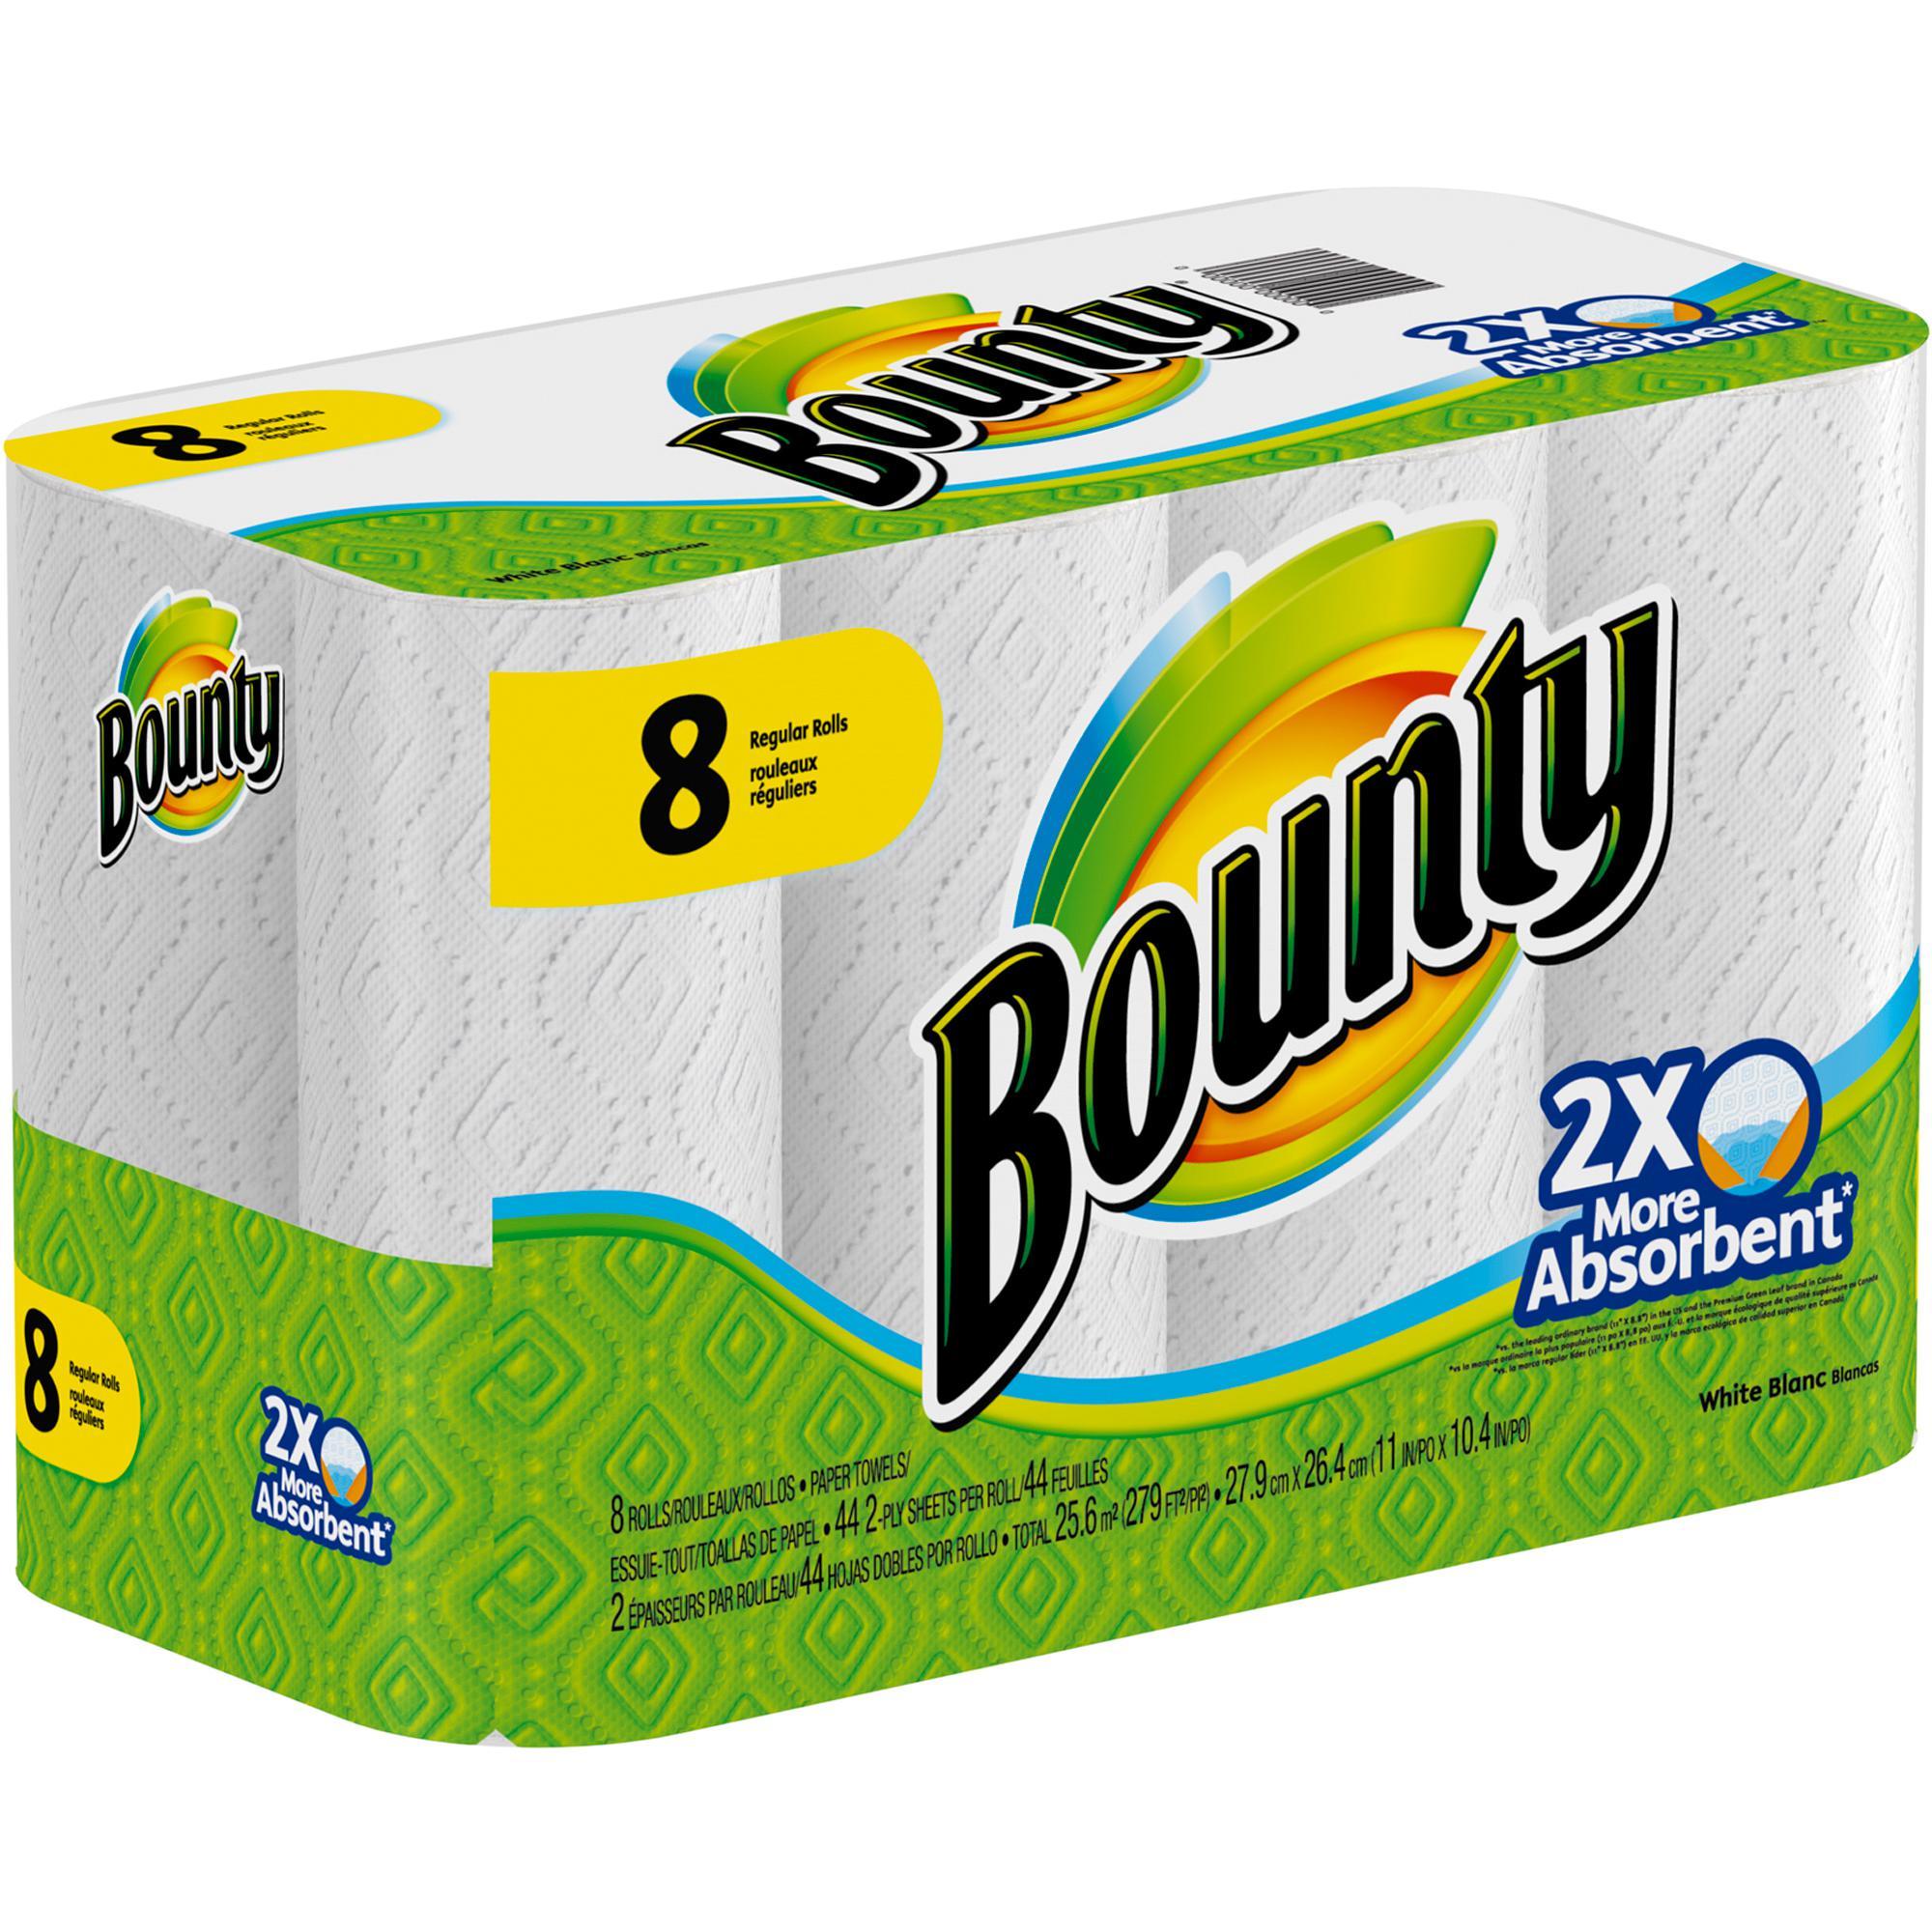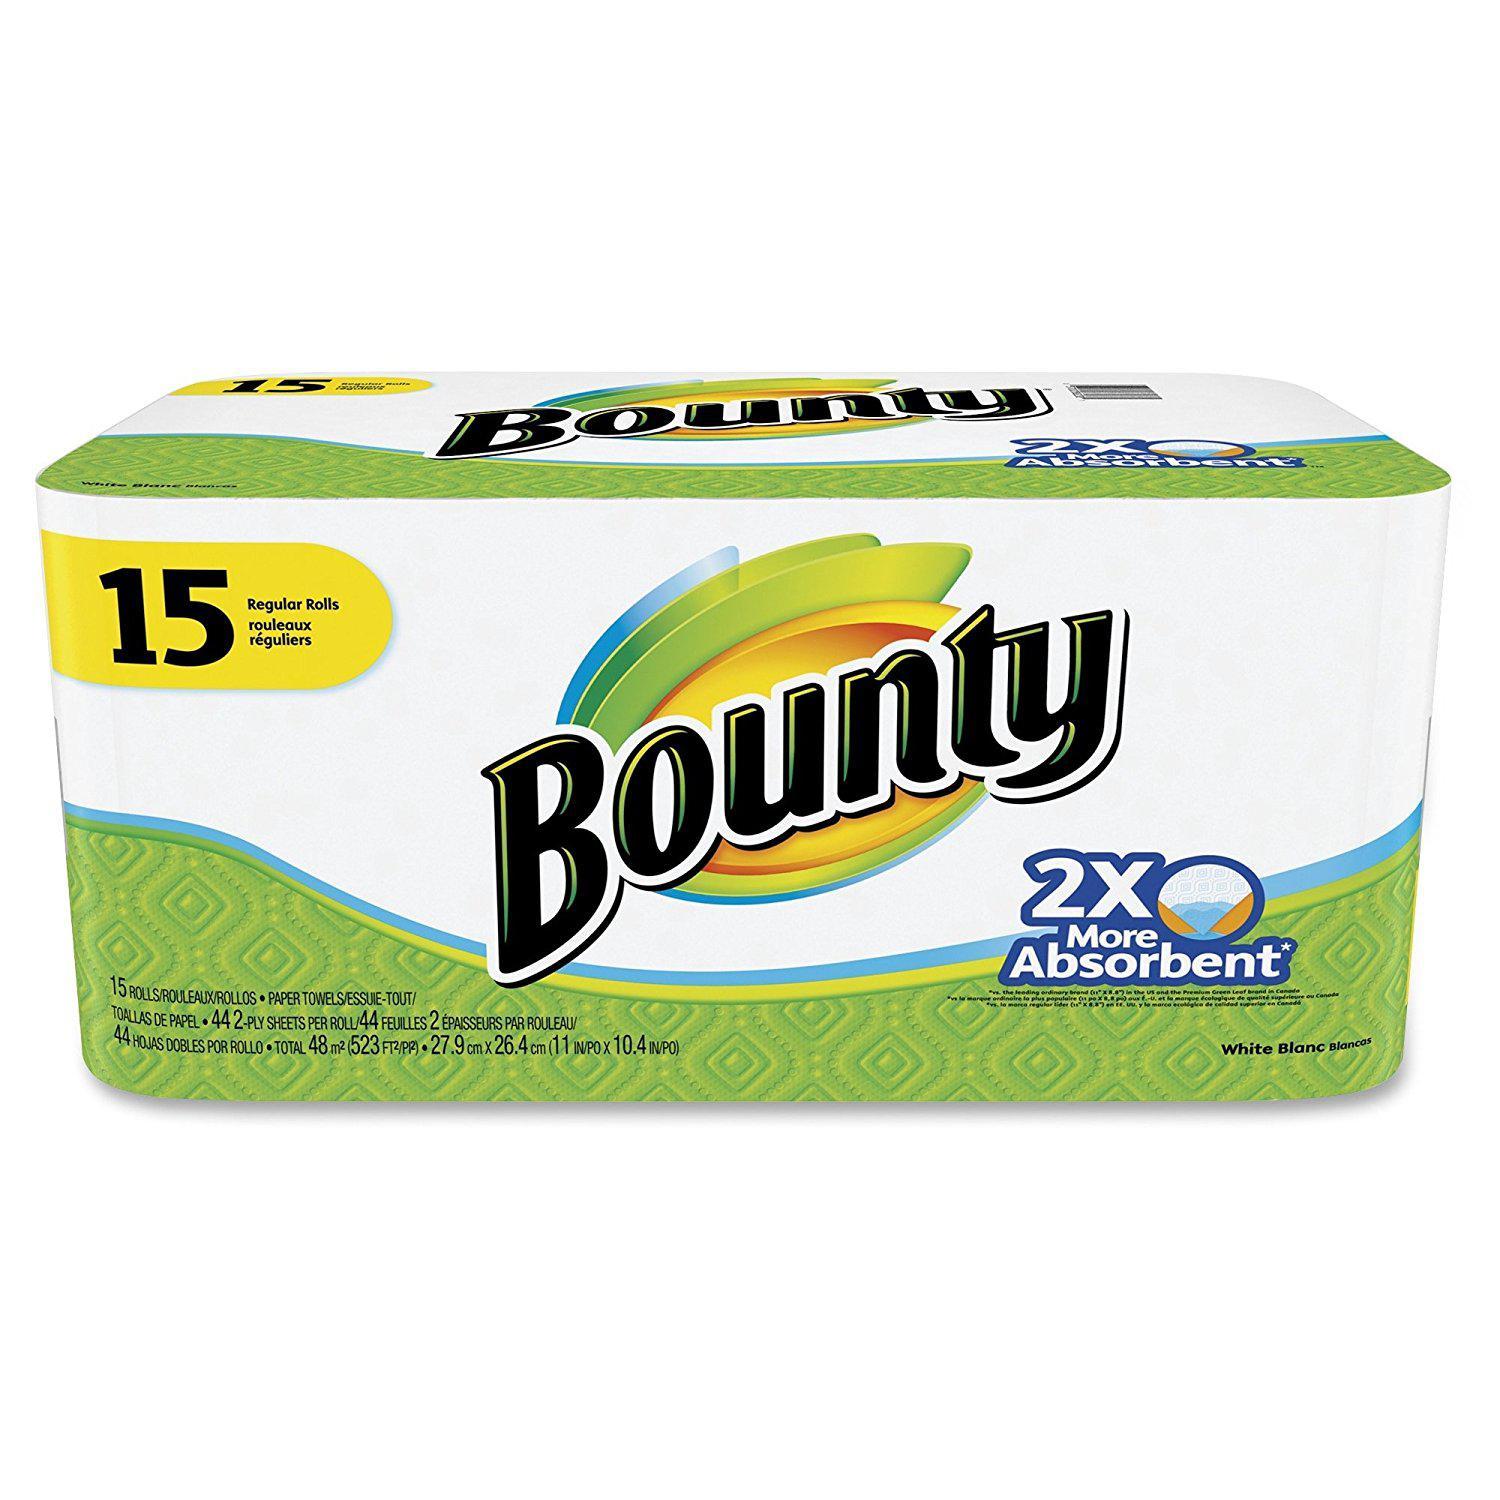The first image is the image on the left, the second image is the image on the right. Assess this claim about the two images: "The left image shows one multi-roll package of towels with a yellow quarter circle in the upper left corner, and the package on the right features the same basic color scheme as the pack on the left.". Correct or not? Answer yes or no. No. The first image is the image on the left, the second image is the image on the right. Evaluate the accuracy of this statement regarding the images: "There is a package that contains larger than regular sized paper towel rolls.". Is it true? Answer yes or no. No. 